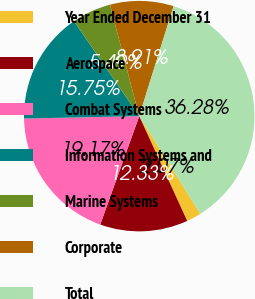Convert chart to OTSL. <chart><loc_0><loc_0><loc_500><loc_500><pie_chart><fcel>Year Ended December 31<fcel>Aerospace<fcel>Combat Systems<fcel>Information Systems and<fcel>Marine Systems<fcel>Corporate<fcel>Total<nl><fcel>2.07%<fcel>12.33%<fcel>19.17%<fcel>15.75%<fcel>5.49%<fcel>8.91%<fcel>36.28%<nl></chart> 